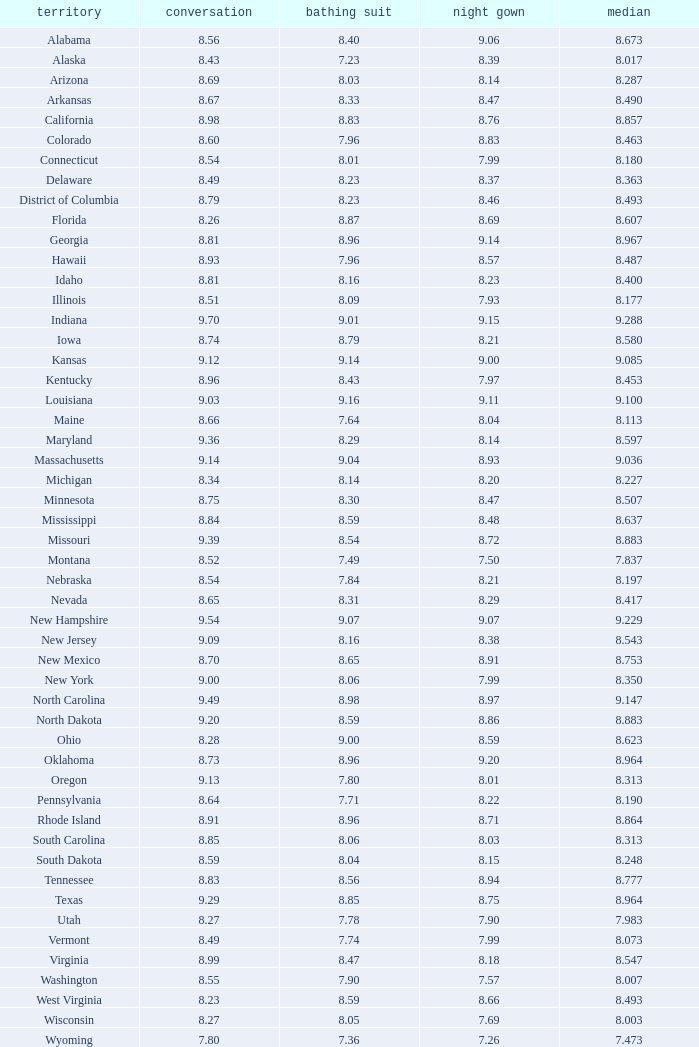Name the state with an evening gown more than 8.86 and interview less than 8.7 and swimsuit less than 8.96 Alabama. 